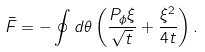<formula> <loc_0><loc_0><loc_500><loc_500>\bar { F } = - \oint d \theta \left ( \frac { P _ { \phi } \xi } { \sqrt { t } } + \frac { \xi ^ { 2 } } { 4 t } \right ) .</formula> 